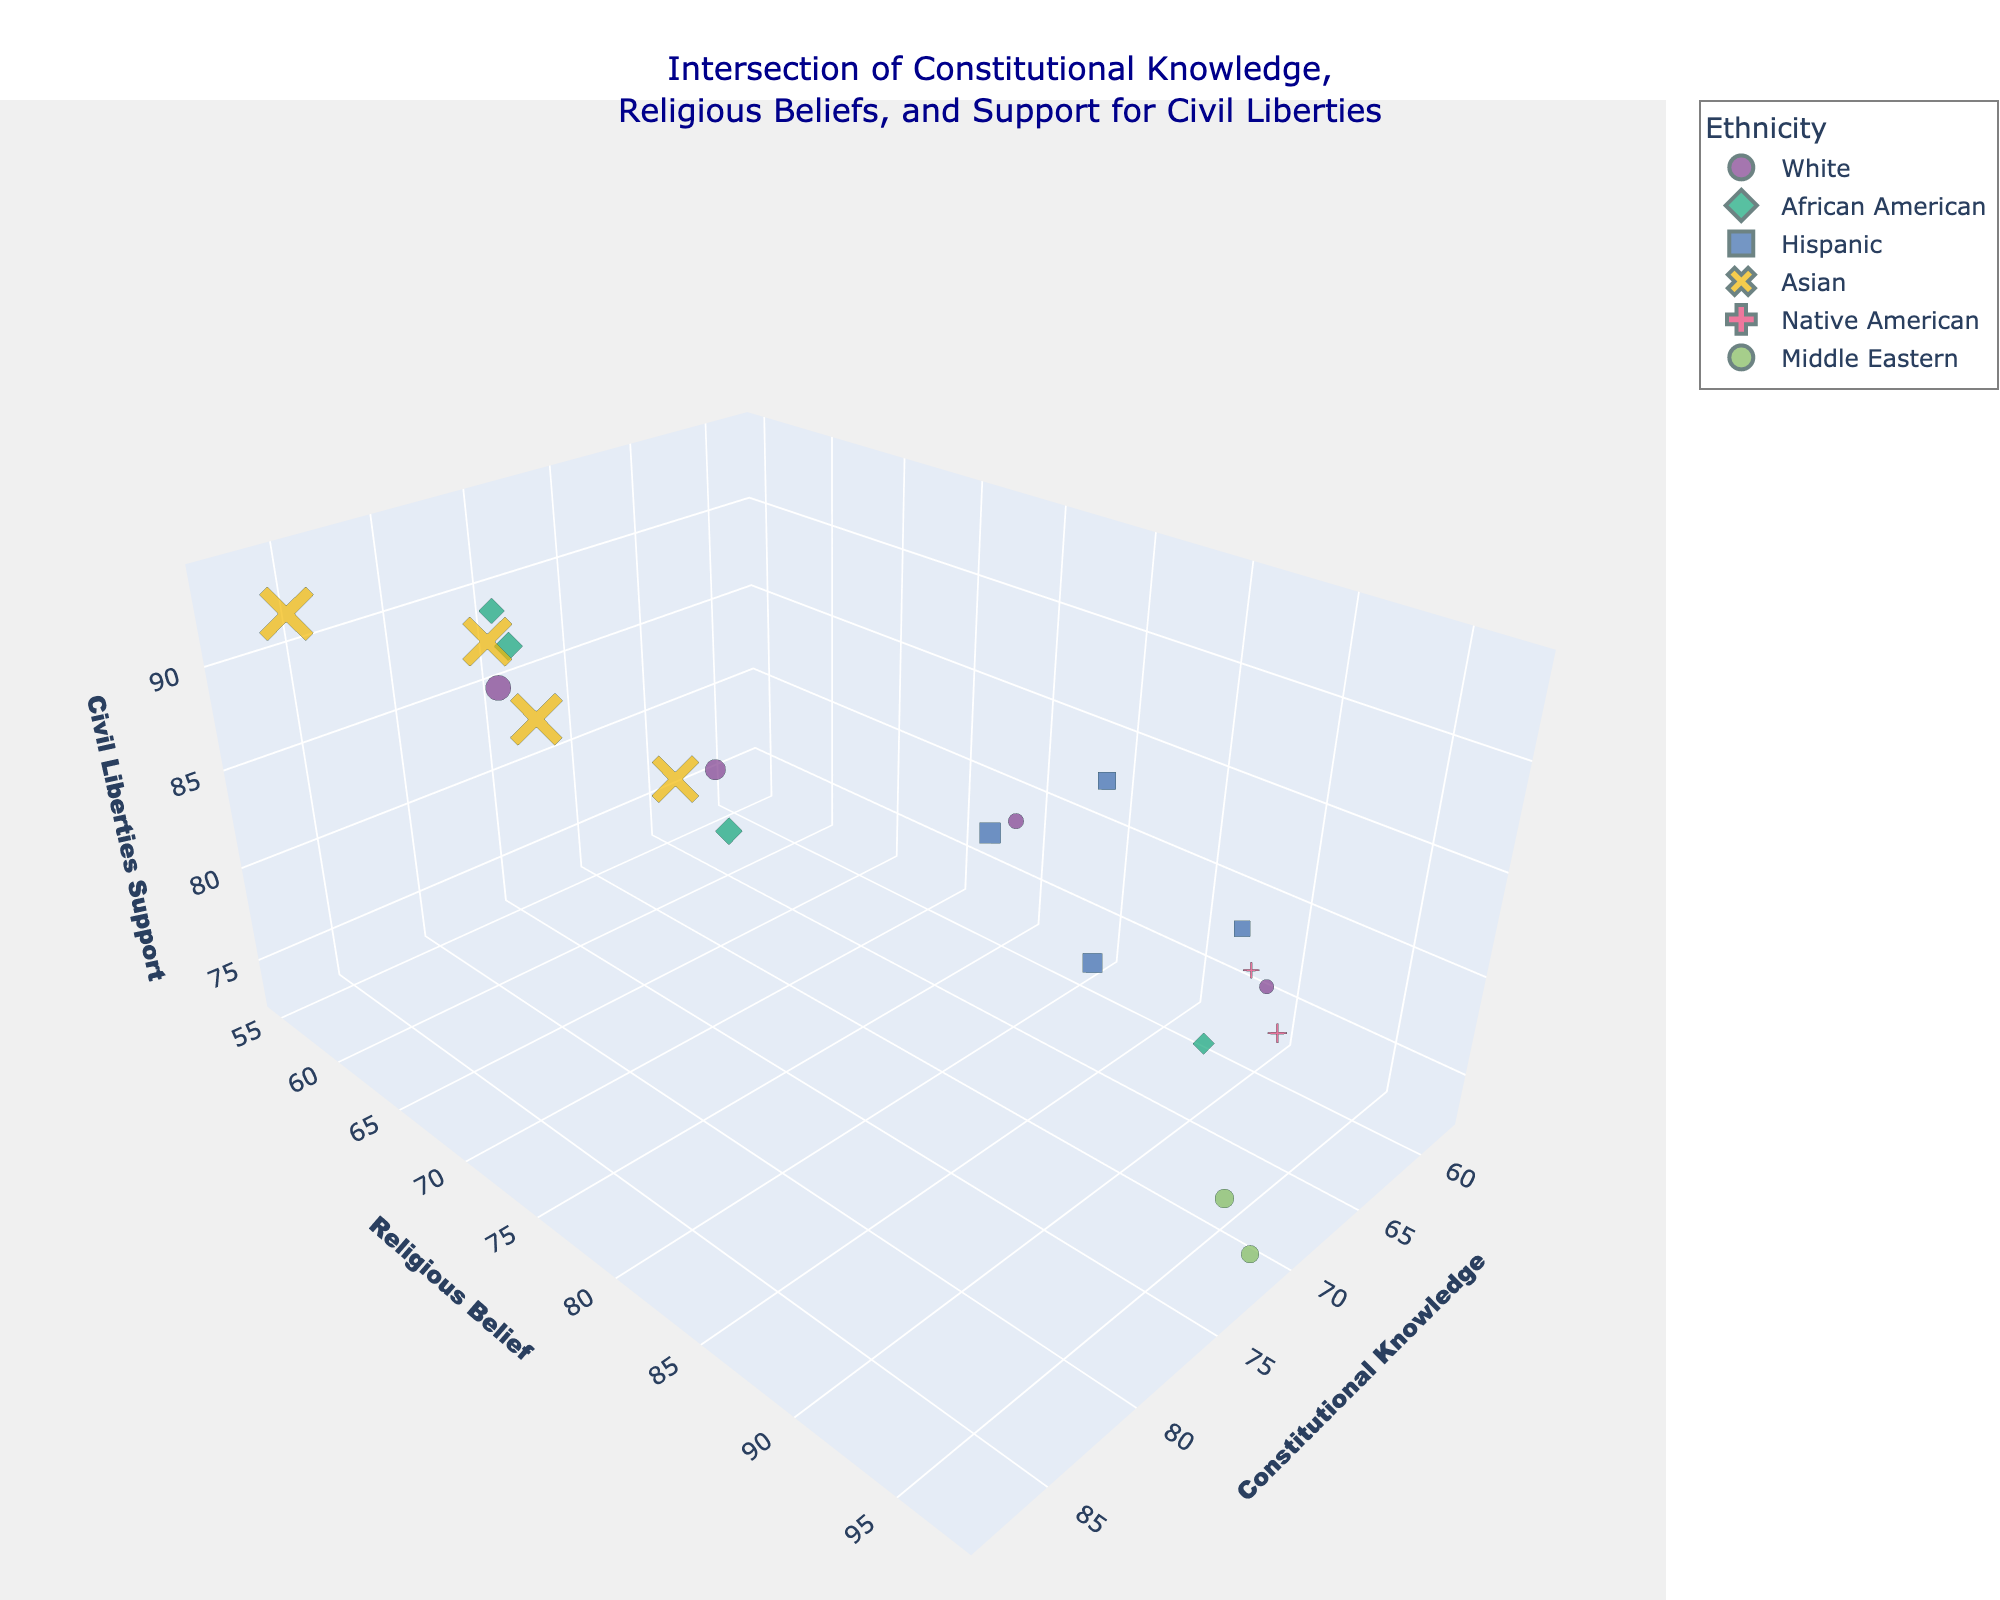What's the title of the figure? The title is usually located at the top of the figure and provides a summary of what the plot is about. In this case, the title of the figure is: "Intersection of Constitutional Knowledge, Religious Beliefs, and Support for Civil Liberties".
Answer: "Intersection of Constitutional Knowledge, Religious Beliefs, and Support for Civil Liberties" Which ethnic group has the highest average Civil Liberties Support? To determine this, find the Civil Liberties Support values for each ethnic group and calculate the averages. Whites have values [88, 93, 87, 77], African Americans have [79, 86, 89, 92], Hispanics have [82, 85, 80, 81], Asians have [91, 90, 88, 94], Native Americans have [76, 78], and Middle Easterns have [74, 73].
Answer: Asians How does Constitutional Knowledge relate to Civil Liberties Support among African Americans? Look at the data points for African Americans and examine the relationship between Constitutional Knowledge and Civil Liberties Support. With points in (68,79), (75,89), (78,86), and (81,92), you can see that higher Constitutional Knowledge tends to correlate with higher Civil Liberties Support.
Answer: Positive correlation What's the relationship between Religious Belief and Civil Liberties Support for the Middle Eastern ethnic group? Identify points for the Middle Eastern group: (95,74) and (97,73). Both have high Religious Beliefs but low Civil Liberties Support.
Answer: High Religious Belief, Low Civil Liberties Support Among the age groups, which one has the highest Constitutional Knowledge? Identify the age groups and find the highest value of Constitutional Knowledge. The value 85 at age 67 shows the highest Constitutional Knowledge.
Answer: Age 67 Which ethnicity has the most diverse range of Constitutional Knowledge values? Look at the range of Constitutional Knowledge values for each ethnicity. Asians range from 79 to 88, while African Americans range from 68 to 81, Whites range from 60 to 85, Hispanics range from 61 to 69, Native Americans range from 58 to 64, and Middle Easterns range from 70 to 71.
Answer: Whites Which ethnic group has the lowest Religious Belief with an age under 30? Focus on data points where age is under 30. Whites (90), Native Americans (93), Hispanics (89), Middle Eastern (97), African Americans (92), and search for the lowest.
Answer: Whites, 60 How does the marker size vary in the plot? The marker size represents the age of the respondents. Bigger markers indicate older age and the smaller ones indicate younger age.
Answer: Size represents age Are there any age groups missing between 20 and 30? List ages between 20 and 30. The ages that appear are 22, 24, 25, 27, and 29. The missing age groups are 20, 21, 23, 26, 28, and 30.
Answer: Yes, ages 20, 21, 23, 26, 28, 30 Which age group and ethnicity combination shows the highest Civil Liberties Support? Look for the highest value in Civil Liberties Support and identify the corresponding age and ethnicity. The highest value of 94 corresponds to an age of 63 and Asian ethnicity.
Answer: Age 63, Asian 